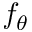Convert formula to latex. <formula><loc_0><loc_0><loc_500><loc_500>f _ { \theta }</formula> 